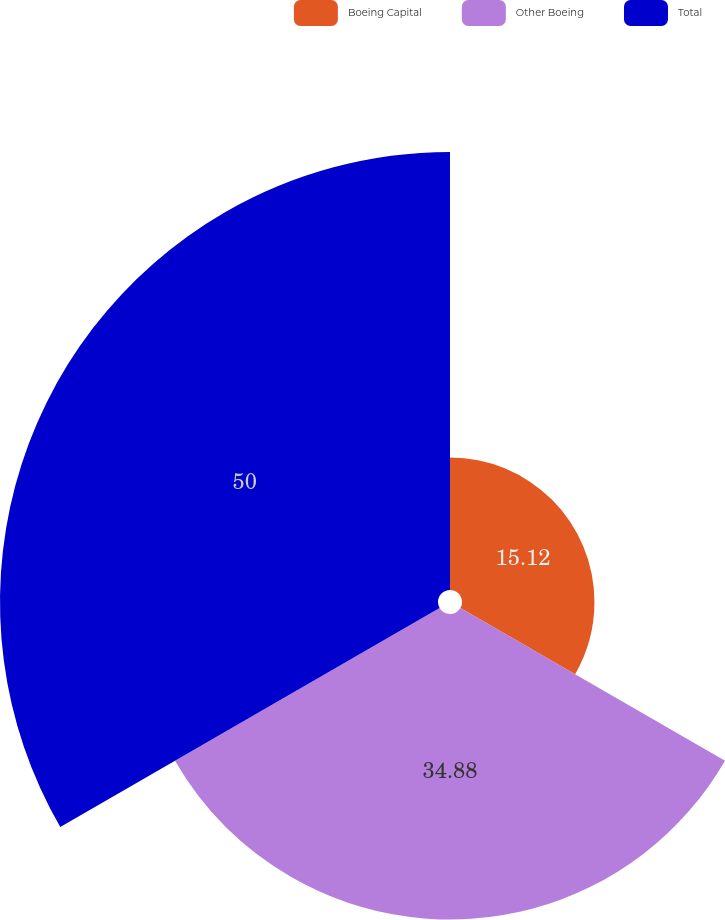Convert chart to OTSL. <chart><loc_0><loc_0><loc_500><loc_500><pie_chart><fcel>Boeing Capital<fcel>Other Boeing<fcel>Total<nl><fcel>15.12%<fcel>34.88%<fcel>50.0%<nl></chart> 